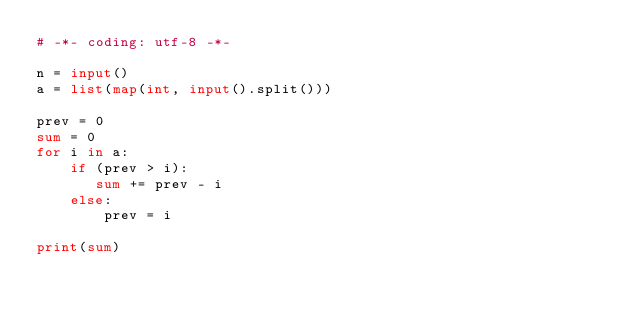<code> <loc_0><loc_0><loc_500><loc_500><_Python_># -*- coding: utf-8 -*-

n = input()
a = list(map(int, input().split()))

prev = 0
sum = 0
for i in a:
    if (prev > i):
       sum += prev - i
    else:
        prev = i

print(sum)</code> 